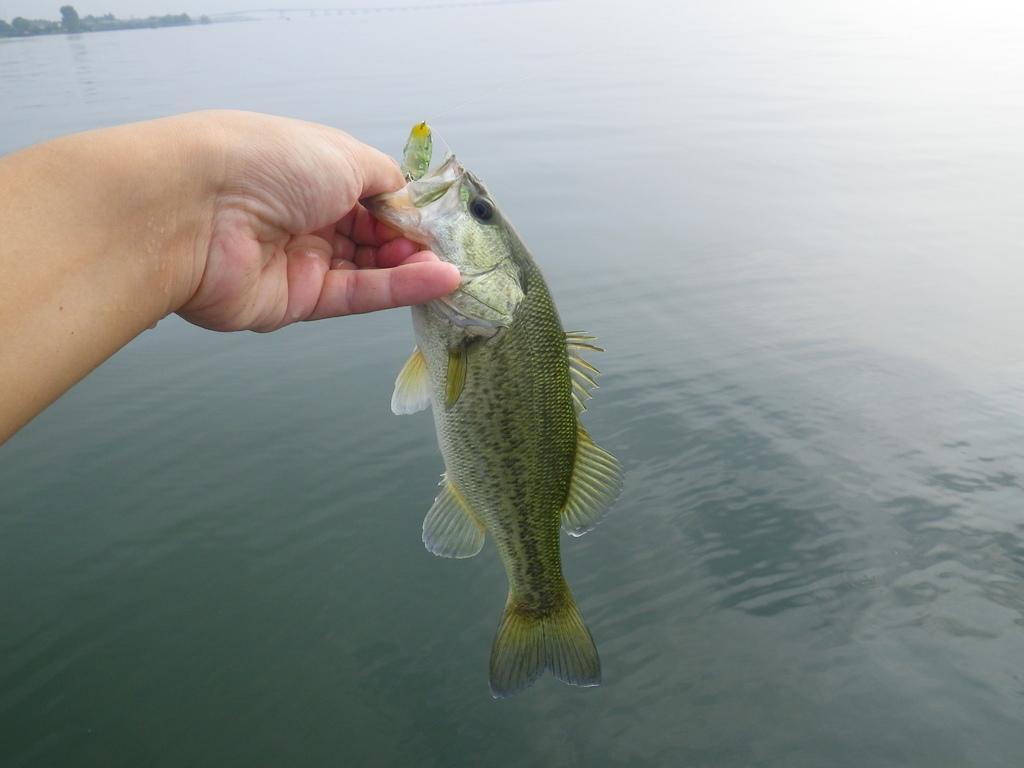Could you give a brief overview of what you see in this image? In the image there is a hand holding a fish with the fingers and under the fish there is a water surface. 